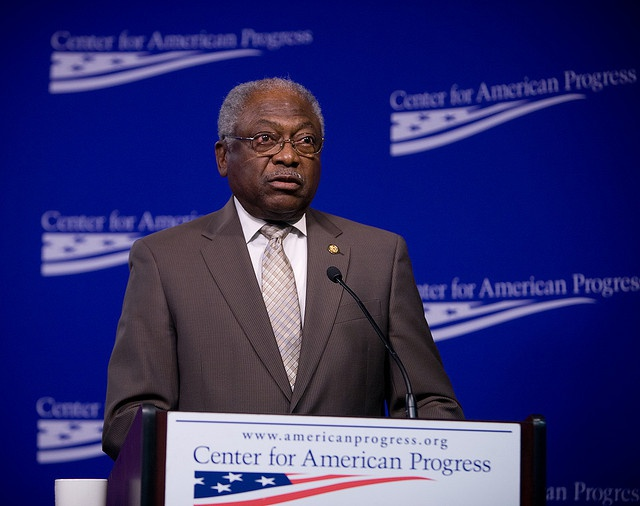Describe the objects in this image and their specific colors. I can see people in navy, black, and brown tones and tie in navy, lightgray, and darkgray tones in this image. 